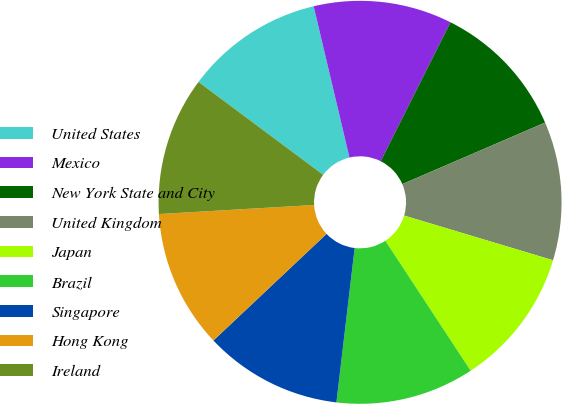<chart> <loc_0><loc_0><loc_500><loc_500><pie_chart><fcel>United States<fcel>Mexico<fcel>New York State and City<fcel>United Kingdom<fcel>Japan<fcel>Brazil<fcel>Singapore<fcel>Hong Kong<fcel>Ireland<nl><fcel>11.11%<fcel>11.11%<fcel>11.11%<fcel>11.12%<fcel>11.11%<fcel>11.12%<fcel>11.1%<fcel>11.1%<fcel>11.12%<nl></chart> 